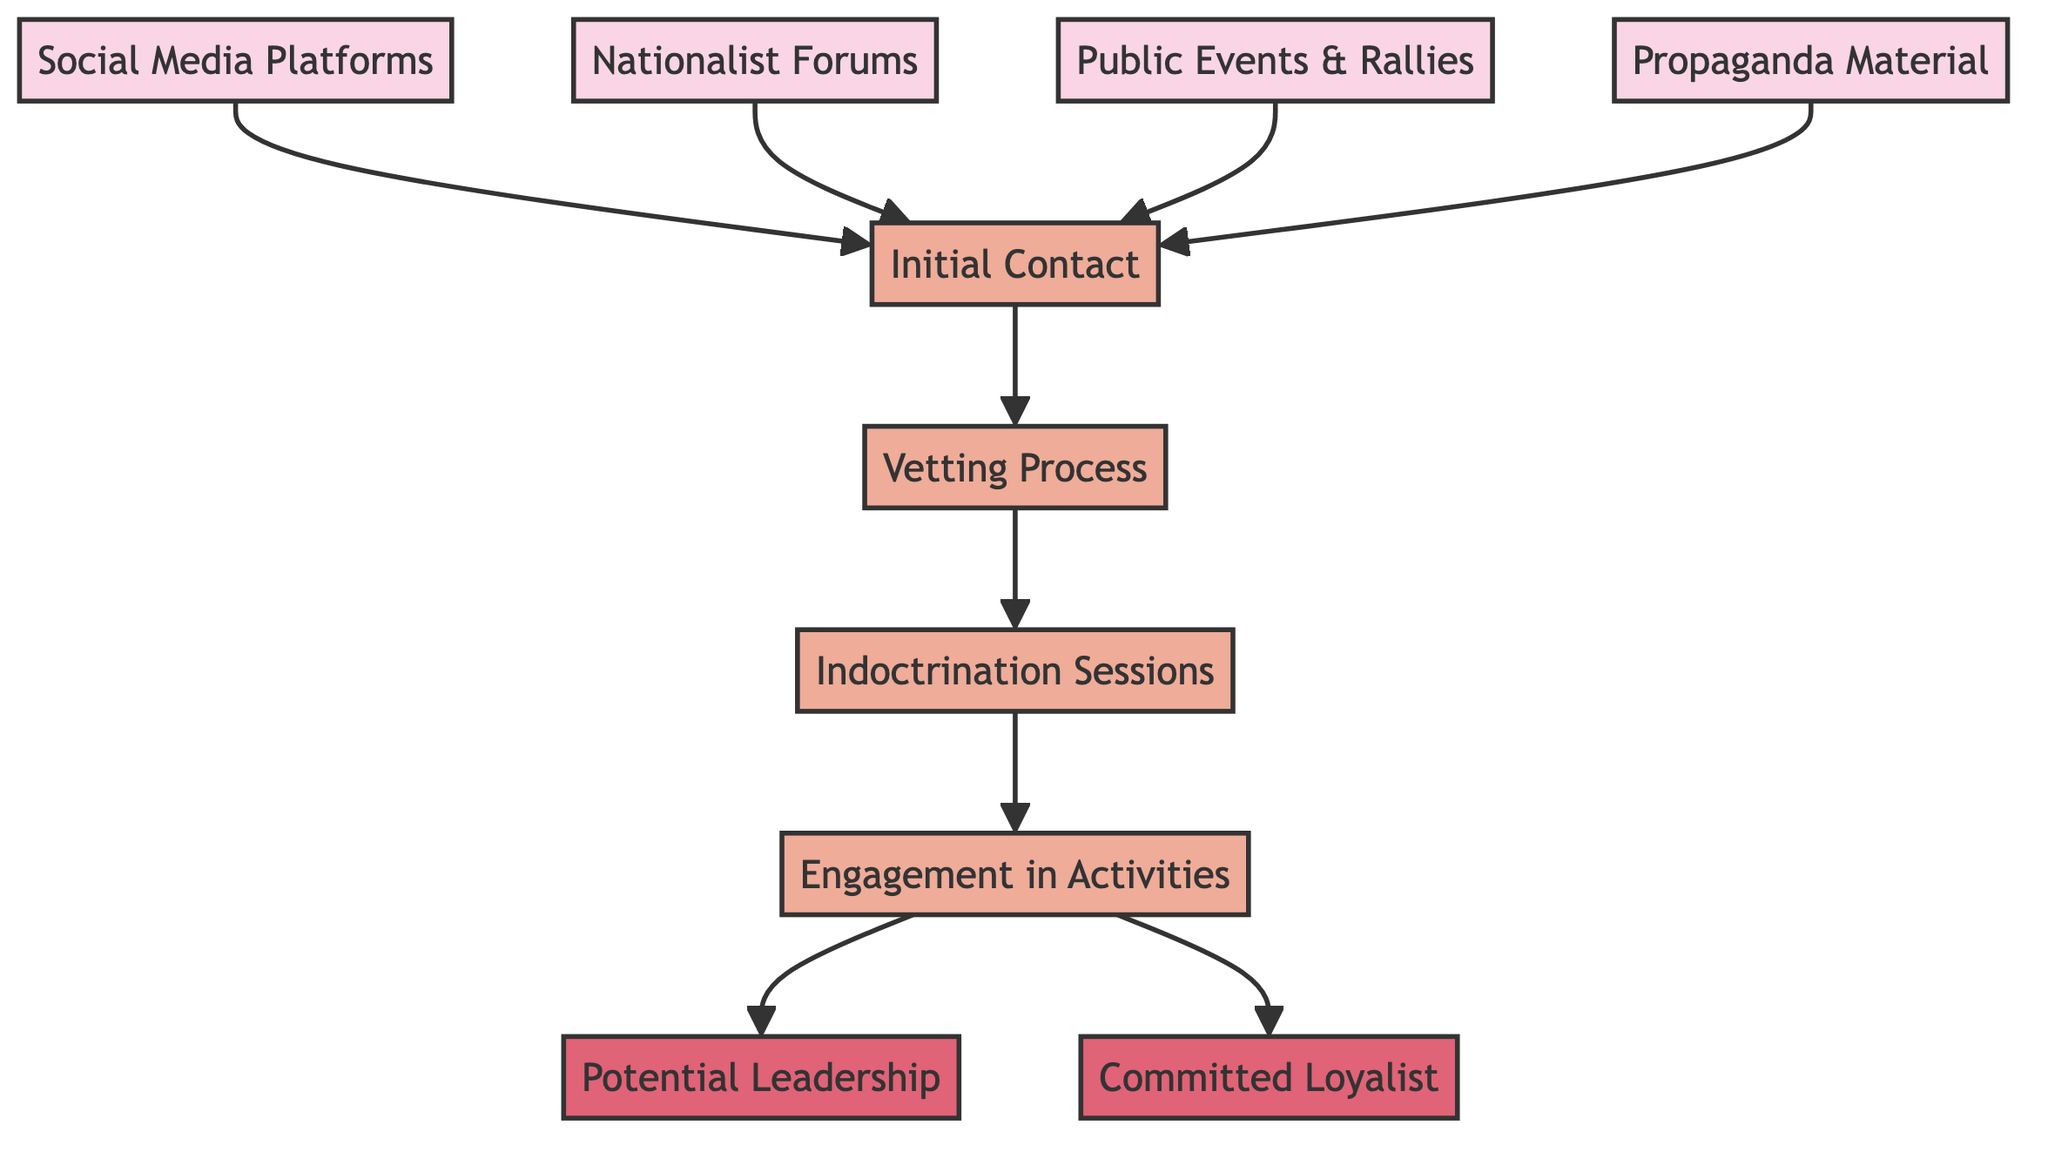What are the entry points for potential recruits? The diagram shows four entry points: "Social Media Platforms," "Nationalist Forums," "Public Events & Rallies," and "Propaganda Material." These nodes indicate where potential recruits can first make contact.
Answer: Social Media Platforms, Nationalist Forums, Public Events & Rallies, Propaganda Material How many nodes are present in the diagram? To find the number of nodes, count each individual node listed in the diagram: there are ten nodes in total, including the outcomes and processes.
Answer: Ten What is the first step a new member must take after the initial contact? The flows indicate that after "Initial Contact," the next step is the "Vetting Process." This shows the sequential progression for new members moving through the recruitment funnel.
Answer: Vetting Process What is required for transitioning from indoctrination to engagement? The diagram denotes a direct edge from "Indoctrination Sessions" to "Engagement in Activities," indicating that successful completion of indoctrination leads directly to engagement.
Answer: Engagement in Activities How many potential outcomes are there for members engaged in activities? Analyzing the flow from "Engagement," there are two outcomes: "Potential Leadership" and "Committed Loyalist," indicating that engaged members can either move towards leadership roles or solidify their commitment.
Answer: Two Which node represents a critical evaluation before indoctrination? The "Vetting Process" node acts as a gatekeeper step that evaluates potential recruits before they are subject to indoctrination sessions, ensuring they align with group values.
Answer: Vetting Process What role do social media platforms play in recruitment? "Social Media Platforms" serve as an entry point, providing a pathway for potential recruits to make their initial contact with the activist group, highlighting the importance of digital influence.
Answer: Initial Contact What must happen after the vetting process? Following the "Vetting Process," candidates must go through "Indoctrination Sessions," underscoring the planned sequence of infiltration and belief reinforcement in the group.
Answer: Indoctrination Sessions What are the outcomes of engagement in activities? From the node "Engagement in Activities," members can transition to either being recognized as "Potential Leadership" or becoming a "Committed Loyalist," illustrating the different paths available.
Answer: Potential Leadership, Committed Loyalist 